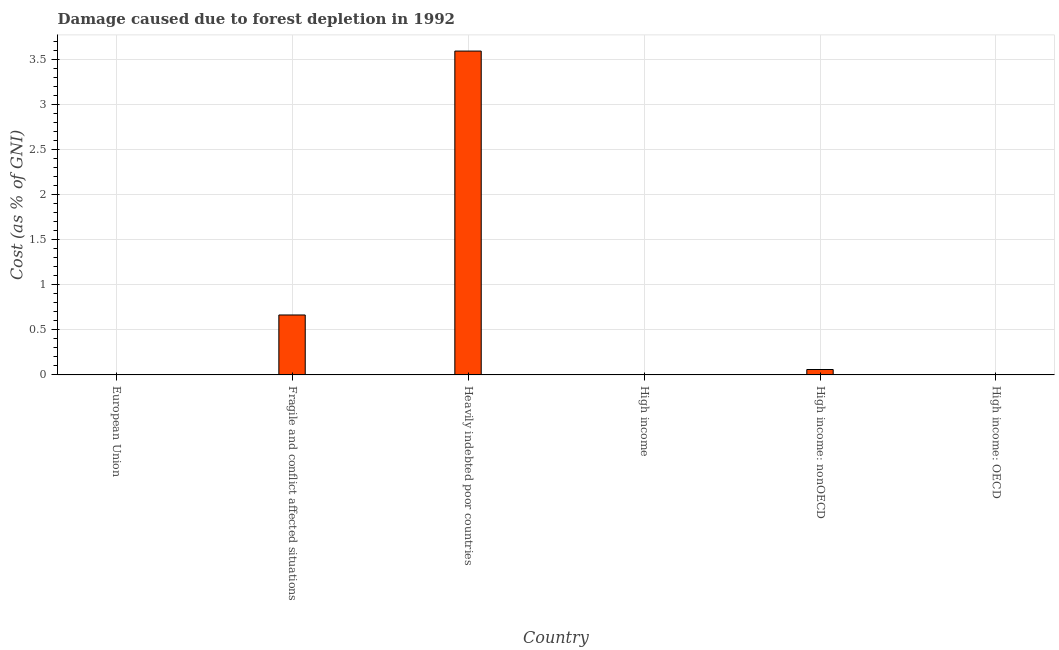What is the title of the graph?
Offer a very short reply. Damage caused due to forest depletion in 1992. What is the label or title of the Y-axis?
Ensure brevity in your answer.  Cost (as % of GNI). What is the damage caused due to forest depletion in High income: nonOECD?
Keep it short and to the point. 0.06. Across all countries, what is the maximum damage caused due to forest depletion?
Ensure brevity in your answer.  3.59. Across all countries, what is the minimum damage caused due to forest depletion?
Provide a short and direct response. 0. In which country was the damage caused due to forest depletion maximum?
Your answer should be very brief. Heavily indebted poor countries. In which country was the damage caused due to forest depletion minimum?
Your answer should be very brief. High income: OECD. What is the sum of the damage caused due to forest depletion?
Your response must be concise. 4.32. What is the difference between the damage caused due to forest depletion in European Union and Fragile and conflict affected situations?
Make the answer very short. -0.66. What is the average damage caused due to forest depletion per country?
Your answer should be very brief. 0.72. What is the median damage caused due to forest depletion?
Provide a short and direct response. 0.03. What is the ratio of the damage caused due to forest depletion in European Union to that in Fragile and conflict affected situations?
Ensure brevity in your answer.  0. Is the damage caused due to forest depletion in European Union less than that in Fragile and conflict affected situations?
Ensure brevity in your answer.  Yes. Is the difference between the damage caused due to forest depletion in High income and High income: OECD greater than the difference between any two countries?
Give a very brief answer. No. What is the difference between the highest and the second highest damage caused due to forest depletion?
Provide a short and direct response. 2.93. What is the difference between the highest and the lowest damage caused due to forest depletion?
Keep it short and to the point. 3.59. What is the difference between two consecutive major ticks on the Y-axis?
Keep it short and to the point. 0.5. Are the values on the major ticks of Y-axis written in scientific E-notation?
Offer a very short reply. No. What is the Cost (as % of GNI) in European Union?
Offer a very short reply. 0. What is the Cost (as % of GNI) of Fragile and conflict affected situations?
Keep it short and to the point. 0.66. What is the Cost (as % of GNI) in Heavily indebted poor countries?
Offer a terse response. 3.59. What is the Cost (as % of GNI) of High income?
Ensure brevity in your answer.  0. What is the Cost (as % of GNI) in High income: nonOECD?
Your response must be concise. 0.06. What is the Cost (as % of GNI) of High income: OECD?
Ensure brevity in your answer.  0. What is the difference between the Cost (as % of GNI) in European Union and Fragile and conflict affected situations?
Offer a very short reply. -0.66. What is the difference between the Cost (as % of GNI) in European Union and Heavily indebted poor countries?
Your response must be concise. -3.59. What is the difference between the Cost (as % of GNI) in European Union and High income?
Make the answer very short. -0. What is the difference between the Cost (as % of GNI) in European Union and High income: nonOECD?
Your answer should be compact. -0.06. What is the difference between the Cost (as % of GNI) in European Union and High income: OECD?
Your answer should be very brief. 0. What is the difference between the Cost (as % of GNI) in Fragile and conflict affected situations and Heavily indebted poor countries?
Provide a short and direct response. -2.93. What is the difference between the Cost (as % of GNI) in Fragile and conflict affected situations and High income?
Keep it short and to the point. 0.66. What is the difference between the Cost (as % of GNI) in Fragile and conflict affected situations and High income: nonOECD?
Provide a short and direct response. 0.6. What is the difference between the Cost (as % of GNI) in Fragile and conflict affected situations and High income: OECD?
Give a very brief answer. 0.66. What is the difference between the Cost (as % of GNI) in Heavily indebted poor countries and High income?
Keep it short and to the point. 3.59. What is the difference between the Cost (as % of GNI) in Heavily indebted poor countries and High income: nonOECD?
Offer a very short reply. 3.53. What is the difference between the Cost (as % of GNI) in Heavily indebted poor countries and High income: OECD?
Your answer should be very brief. 3.59. What is the difference between the Cost (as % of GNI) in High income and High income: nonOECD?
Provide a succinct answer. -0.06. What is the difference between the Cost (as % of GNI) in High income and High income: OECD?
Provide a succinct answer. 0. What is the difference between the Cost (as % of GNI) in High income: nonOECD and High income: OECD?
Your response must be concise. 0.06. What is the ratio of the Cost (as % of GNI) in European Union to that in Fragile and conflict affected situations?
Keep it short and to the point. 0. What is the ratio of the Cost (as % of GNI) in European Union to that in Heavily indebted poor countries?
Provide a short and direct response. 0. What is the ratio of the Cost (as % of GNI) in European Union to that in High income?
Your response must be concise. 0.4. What is the ratio of the Cost (as % of GNI) in European Union to that in High income: nonOECD?
Your answer should be very brief. 0.03. What is the ratio of the Cost (as % of GNI) in European Union to that in High income: OECD?
Make the answer very short. 1.51. What is the ratio of the Cost (as % of GNI) in Fragile and conflict affected situations to that in Heavily indebted poor countries?
Your answer should be compact. 0.18. What is the ratio of the Cost (as % of GNI) in Fragile and conflict affected situations to that in High income?
Your answer should be compact. 180.27. What is the ratio of the Cost (as % of GNI) in Fragile and conflict affected situations to that in High income: nonOECD?
Your answer should be very brief. 11.09. What is the ratio of the Cost (as % of GNI) in Fragile and conflict affected situations to that in High income: OECD?
Keep it short and to the point. 675.03. What is the ratio of the Cost (as % of GNI) in Heavily indebted poor countries to that in High income?
Offer a very short reply. 974.17. What is the ratio of the Cost (as % of GNI) in Heavily indebted poor countries to that in High income: nonOECD?
Offer a very short reply. 59.92. What is the ratio of the Cost (as % of GNI) in Heavily indebted poor countries to that in High income: OECD?
Your answer should be very brief. 3647.76. What is the ratio of the Cost (as % of GNI) in High income to that in High income: nonOECD?
Provide a succinct answer. 0.06. What is the ratio of the Cost (as % of GNI) in High income to that in High income: OECD?
Offer a very short reply. 3.74. What is the ratio of the Cost (as % of GNI) in High income: nonOECD to that in High income: OECD?
Make the answer very short. 60.87. 